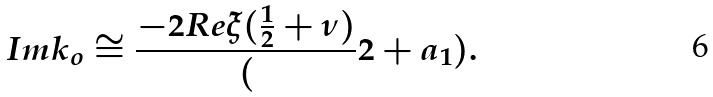Convert formula to latex. <formula><loc_0><loc_0><loc_500><loc_500>I m k _ { o } \cong \frac { - 2 R e \xi ( \frac { 1 } { 2 } + \nu ) } ( 2 + a _ { 1 } ) .</formula> 